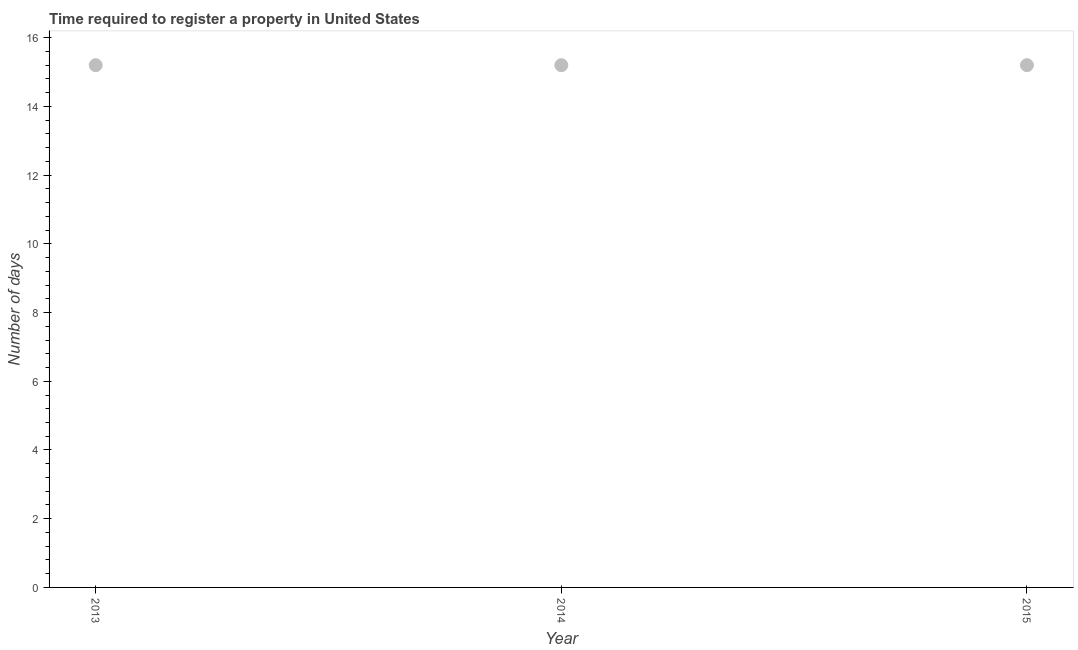What is the number of days required to register property in 2015?
Give a very brief answer. 15.2. Across all years, what is the minimum number of days required to register property?
Offer a very short reply. 15.2. In which year was the number of days required to register property minimum?
Keep it short and to the point. 2013. What is the sum of the number of days required to register property?
Offer a very short reply. 45.6. What is the average number of days required to register property per year?
Ensure brevity in your answer.  15.2. What is the median number of days required to register property?
Make the answer very short. 15.2. Do a majority of the years between 2013 and 2014 (inclusive) have number of days required to register property greater than 8.8 days?
Make the answer very short. Yes. What is the ratio of the number of days required to register property in 2013 to that in 2014?
Ensure brevity in your answer.  1. Is the difference between the number of days required to register property in 2013 and 2014 greater than the difference between any two years?
Offer a very short reply. Yes. What is the difference between the highest and the second highest number of days required to register property?
Your answer should be very brief. 0. Is the sum of the number of days required to register property in 2014 and 2015 greater than the maximum number of days required to register property across all years?
Ensure brevity in your answer.  Yes. What is the difference between the highest and the lowest number of days required to register property?
Make the answer very short. 0. In how many years, is the number of days required to register property greater than the average number of days required to register property taken over all years?
Your answer should be compact. 3. Does the number of days required to register property monotonically increase over the years?
Your answer should be compact. No. What is the difference between two consecutive major ticks on the Y-axis?
Your answer should be compact. 2. Are the values on the major ticks of Y-axis written in scientific E-notation?
Offer a terse response. No. Does the graph contain any zero values?
Your answer should be very brief. No. What is the title of the graph?
Provide a short and direct response. Time required to register a property in United States. What is the label or title of the Y-axis?
Your response must be concise. Number of days. What is the Number of days in 2014?
Your answer should be very brief. 15.2. What is the difference between the Number of days in 2013 and 2014?
Provide a succinct answer. 0. What is the difference between the Number of days in 2013 and 2015?
Make the answer very short. 0. What is the ratio of the Number of days in 2013 to that in 2014?
Your answer should be compact. 1. What is the ratio of the Number of days in 2014 to that in 2015?
Make the answer very short. 1. 